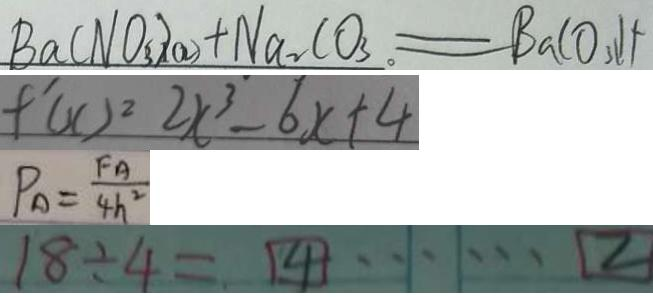Convert formula to latex. <formula><loc_0><loc_0><loc_500><loc_500>B a ( N O _ { 3 } ) _ { 2 } + N a _ { 2 } C O _ { 3 } = B a C O _ { 3 } \downarrow + 
 f ^ { \prime } ( x ) ^ { 2 } 2 x ^ { 3 } - 6 x + 4 
 P _ { A } = \frac { F A } { 4 h ^ { 2 } } 
 1 8 \div 4 = 4 \cdots 2</formula> 